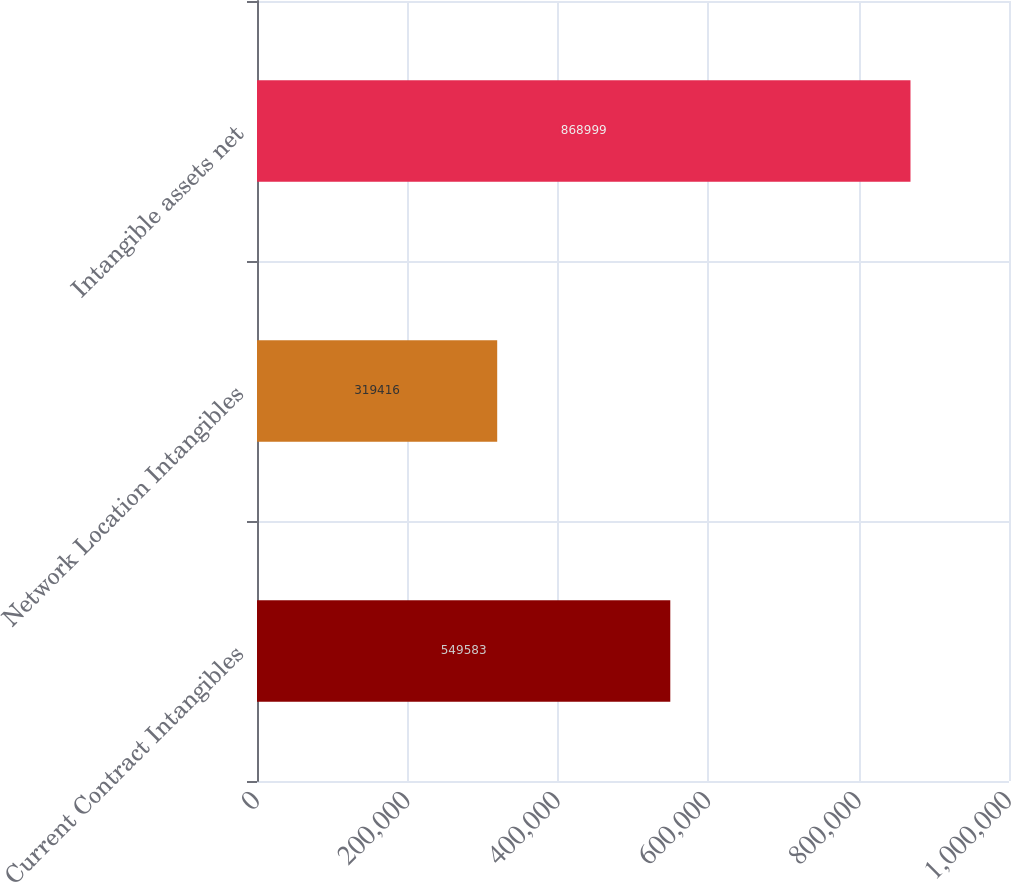Convert chart to OTSL. <chart><loc_0><loc_0><loc_500><loc_500><bar_chart><fcel>Current Contract Intangibles<fcel>Network Location Intangibles<fcel>Intangible assets net<nl><fcel>549583<fcel>319416<fcel>868999<nl></chart> 